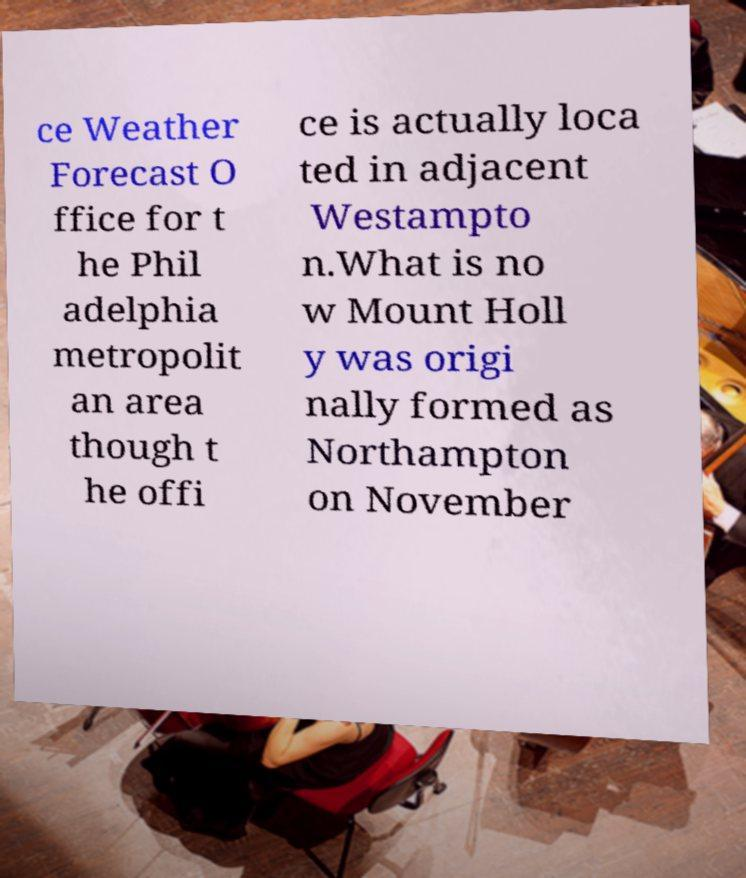Could you assist in decoding the text presented in this image and type it out clearly? ce Weather Forecast O ffice for t he Phil adelphia metropolit an area though t he offi ce is actually loca ted in adjacent Westampto n.What is no w Mount Holl y was origi nally formed as Northampton on November 